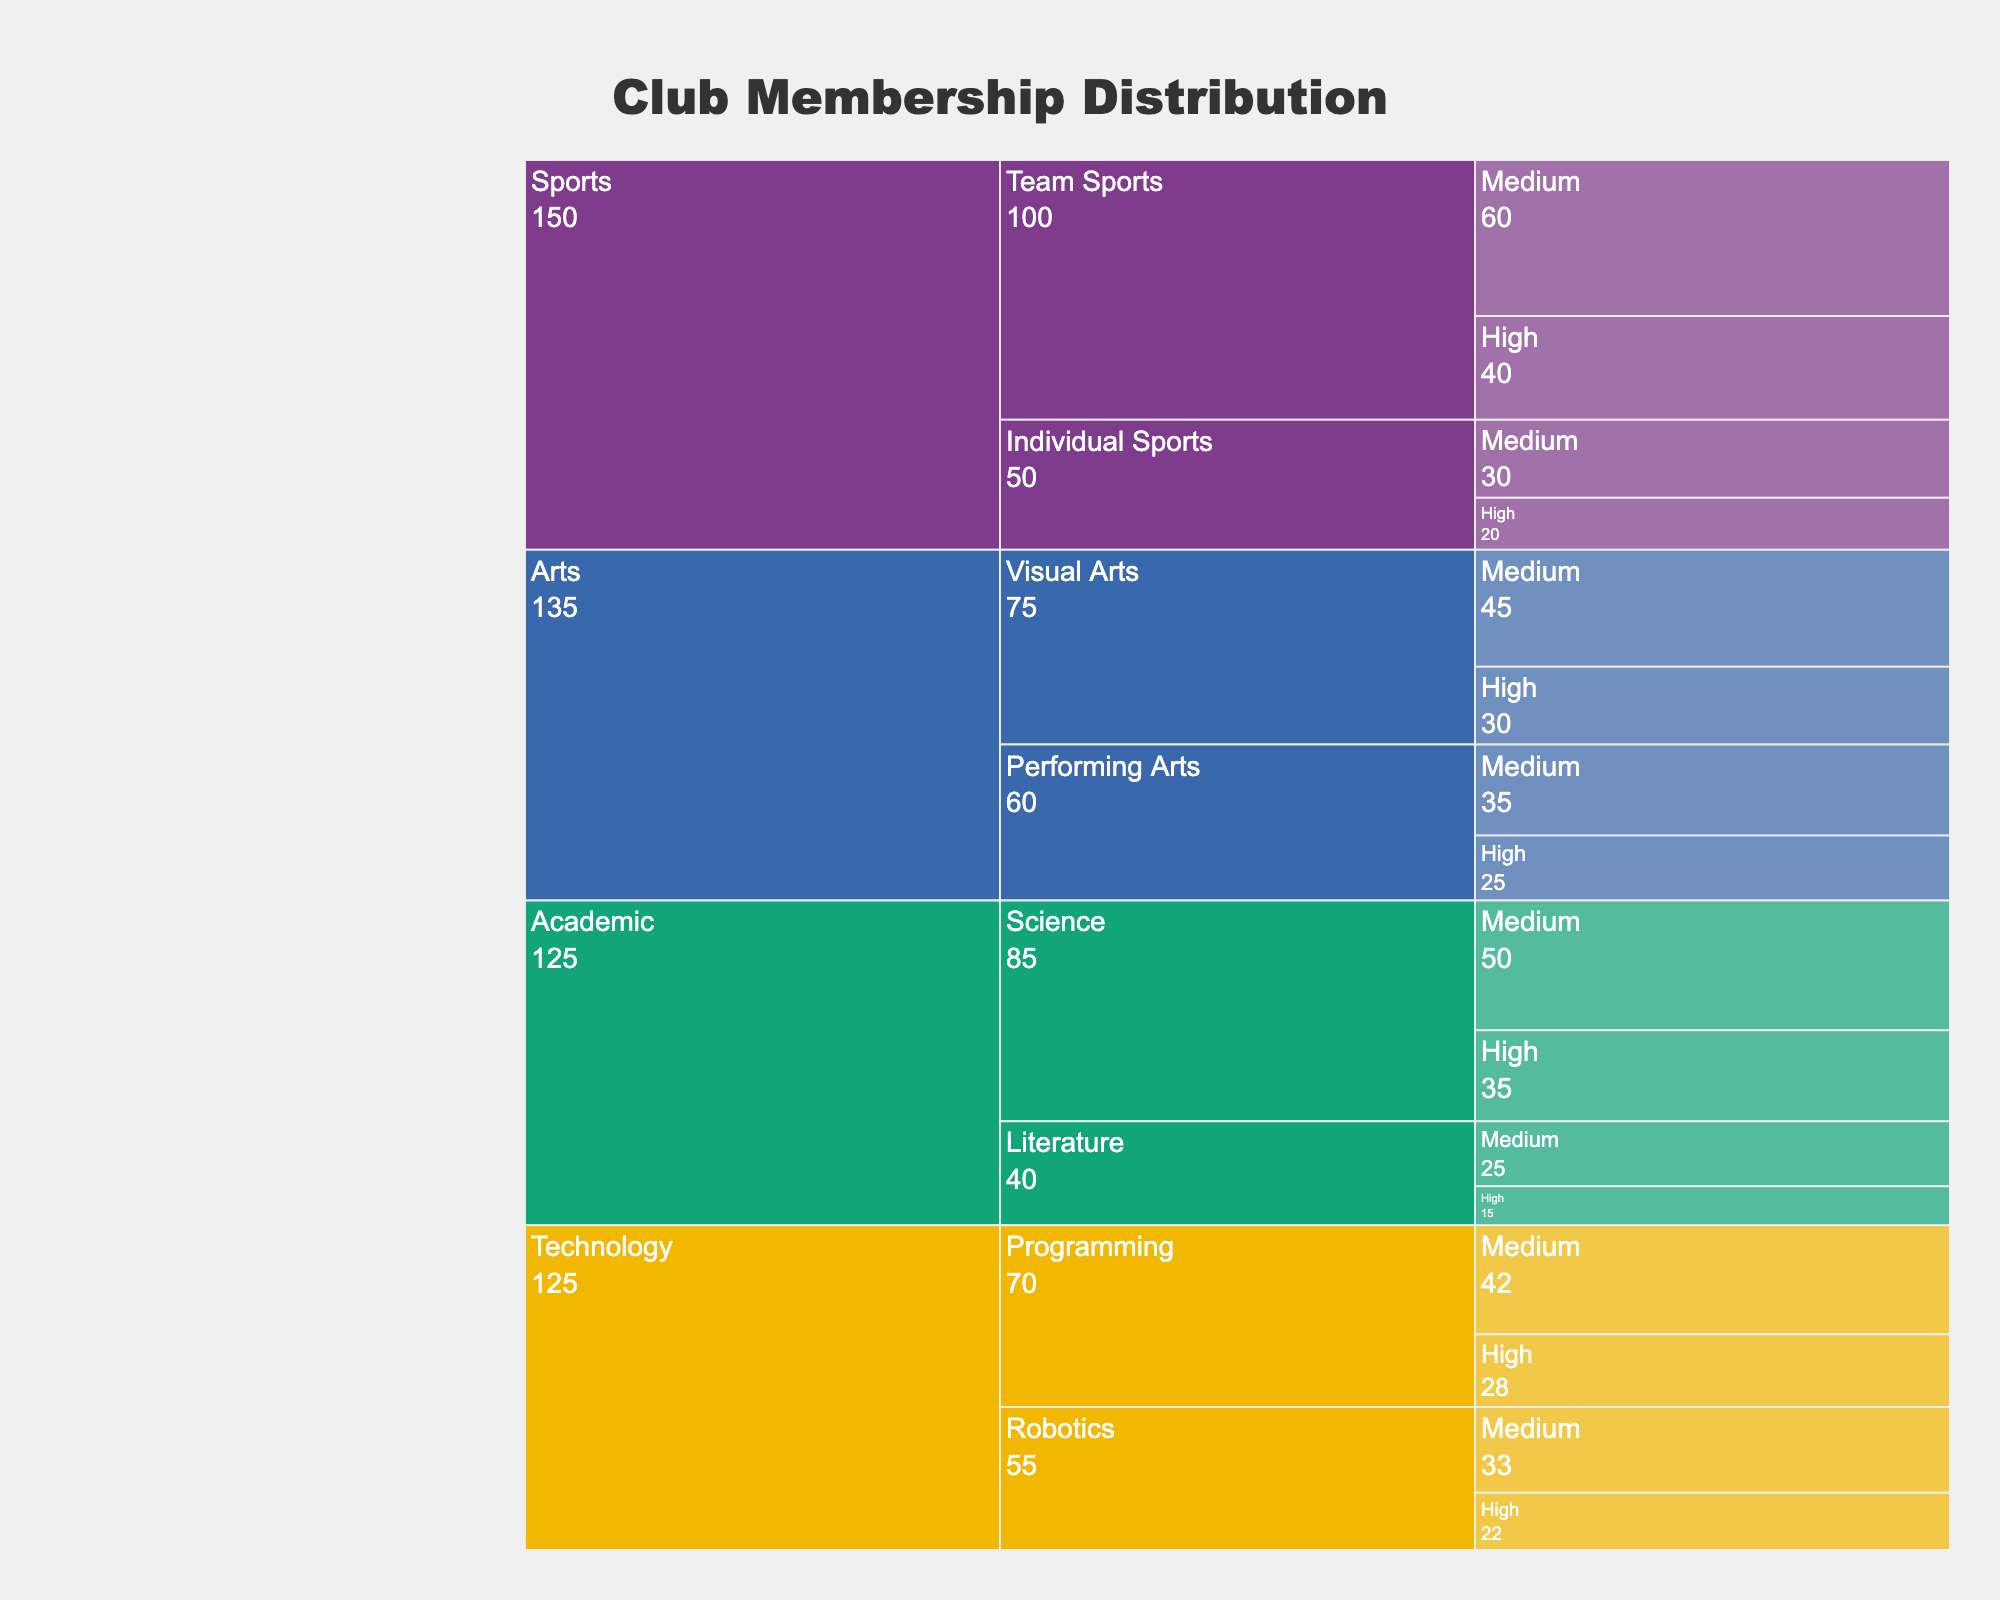What is the title of the figure? The title is shown at the top of the icicle chart and reads "Club Membership Distribution".
Answer: Club Membership Distribution Which interest area has the highest number of total members? To find the interest area with the highest number of members, sum the members for both sub-interests under each interest area. The sums are: Arts (30+45+25+35 = 135), Sports (40+60+20+30 = 150), Academic (35+50+15+25 = 125), Technology (22+33+28+42 = 125). Sports has the highest total.
Answer: Sports How many high-activity members are there in Visual Arts? In the Icicle chart, locate Visual Arts under Arts, then check the number of members under the High activity level.
Answer: 30 Which sub-interest in Technology has more medium-activity members? Compare the number of medium-activity members in Robotics and Programming under Technology. Robotics has 33 members, and Programming has 42 members.
Answer: Programming What is the total number of medium-activity members in the Academic interest area? To find this, sum the medium-activity members in Academic's sub-interests: Science (50) and Literature (25). So, 50 + 25 = 75.
Answer: 75 In the Sports interest area, which sub-interest has fewer members at the high-activity level? Compare high-activity members in Team Sports and Individual Sports under Sports. Team Sports has 40 members, and Individual Sports has 20 members.
Answer: Individual Sports What is the difference in the number of members between high and medium activity levels in Performing Arts? For Performing Arts, calculate the difference between high (25) and medium (35) activity levels: 35 - 25 = 10.
Answer: 10 Which interest area has the most evenly distributed members between High and Medium activity levels? Check each area for how closely matched high and medium activity levels are. Technology's sub-interests have numbers like 22/33 (Robotics) and 28/42 (Programming), which appear more evenly distributed compared to others.
Answer: Technology How many more high-activity members do Team Sports have compared to Individual Sports? Compare high-activity members in Team Sports (40) with Individual Sports (20) under Sports: 40 - 20 = 20.
Answer: 20 